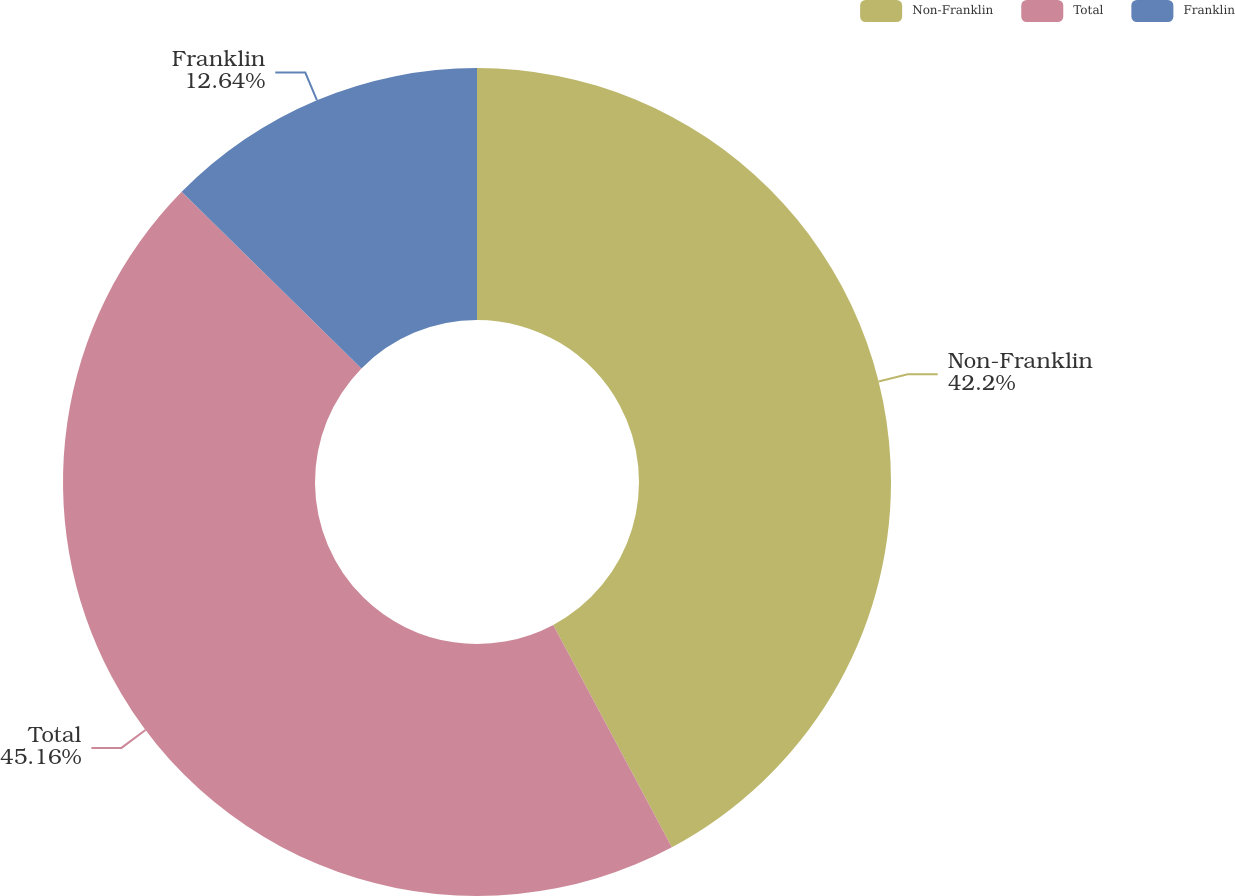<chart> <loc_0><loc_0><loc_500><loc_500><pie_chart><fcel>Non-Franklin<fcel>Total<fcel>Franklin<nl><fcel>42.2%<fcel>45.16%<fcel>12.64%<nl></chart> 